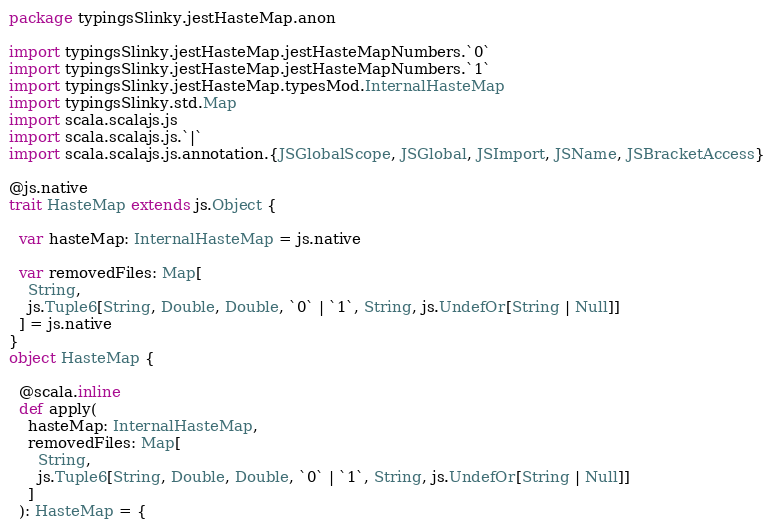<code> <loc_0><loc_0><loc_500><loc_500><_Scala_>package typingsSlinky.jestHasteMap.anon

import typingsSlinky.jestHasteMap.jestHasteMapNumbers.`0`
import typingsSlinky.jestHasteMap.jestHasteMapNumbers.`1`
import typingsSlinky.jestHasteMap.typesMod.InternalHasteMap
import typingsSlinky.std.Map
import scala.scalajs.js
import scala.scalajs.js.`|`
import scala.scalajs.js.annotation.{JSGlobalScope, JSGlobal, JSImport, JSName, JSBracketAccess}

@js.native
trait HasteMap extends js.Object {
  
  var hasteMap: InternalHasteMap = js.native
  
  var removedFiles: Map[
    String, 
    js.Tuple6[String, Double, Double, `0` | `1`, String, js.UndefOr[String | Null]]
  ] = js.native
}
object HasteMap {
  
  @scala.inline
  def apply(
    hasteMap: InternalHasteMap,
    removedFiles: Map[
      String, 
      js.Tuple6[String, Double, Double, `0` | `1`, String, js.UndefOr[String | Null]]
    ]
  ): HasteMap = {</code> 